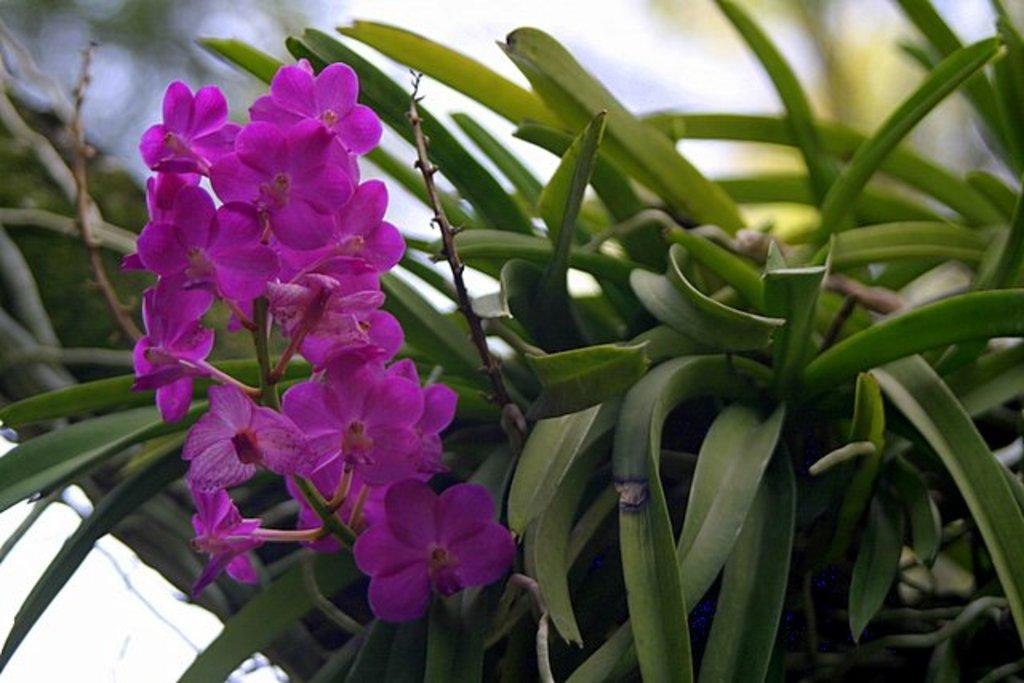What type of plant is in the picture? There is a flower plant in the picture. What color are the flowers on the plant? The flowers on the plant are purple. Can you describe the background of the image? The background of the image is blurred. What is the rate of the rings in the image? There are no rings present in the image, so it is not possible to determine a rate. 